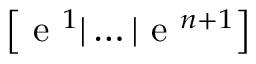<formula> <loc_0><loc_0><loc_500><loc_500>\left [ e ^ { 1 } | \dots | e ^ { n + 1 } \right ]</formula> 